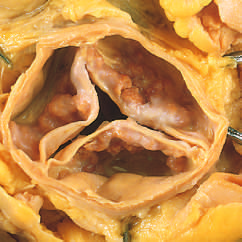one cusp has a partial fusion at whose center?
Answer the question using a single word or phrase. Its 